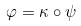Convert formula to latex. <formula><loc_0><loc_0><loc_500><loc_500>\varphi = \kappa \circ \psi</formula> 